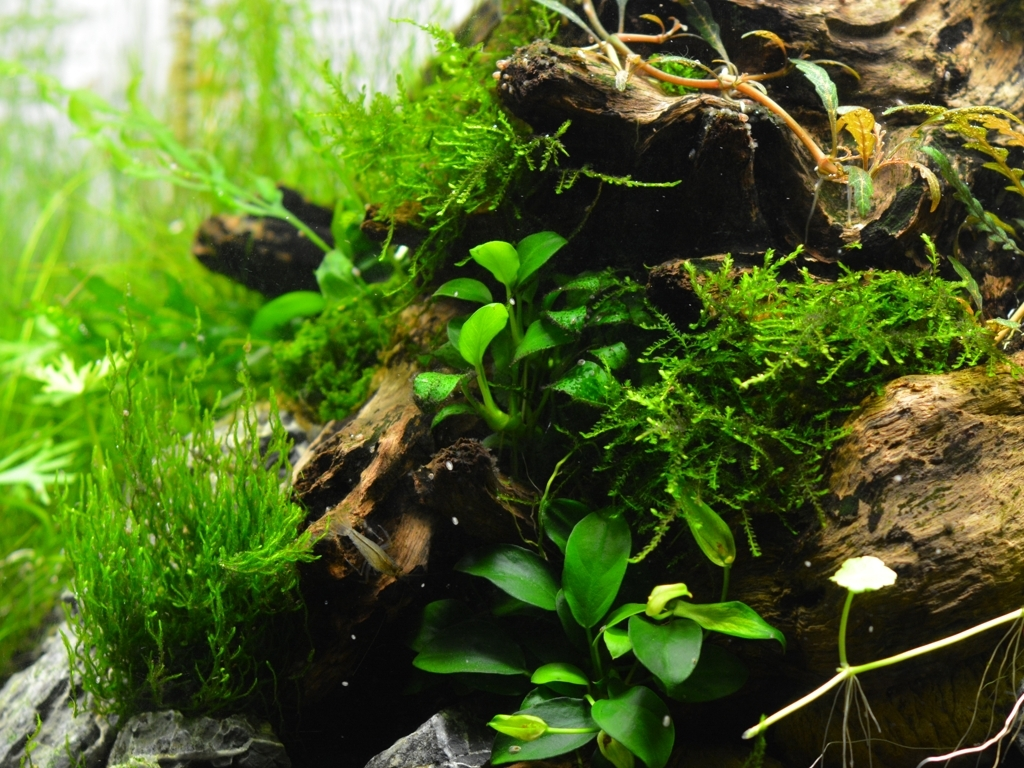Are the features of the main weeds and branches still clear? Yes, the features of the main weeds and branches are quite distinct and visible. The greenery is vibrant, displaying various shades of green, and the textures of the wood and leaves are intricate with rich detail. There is a clear contrast between the aquatic plants, the wood, and the stones which helps to maintain the clarity of the individual elements within the ecosystem. 